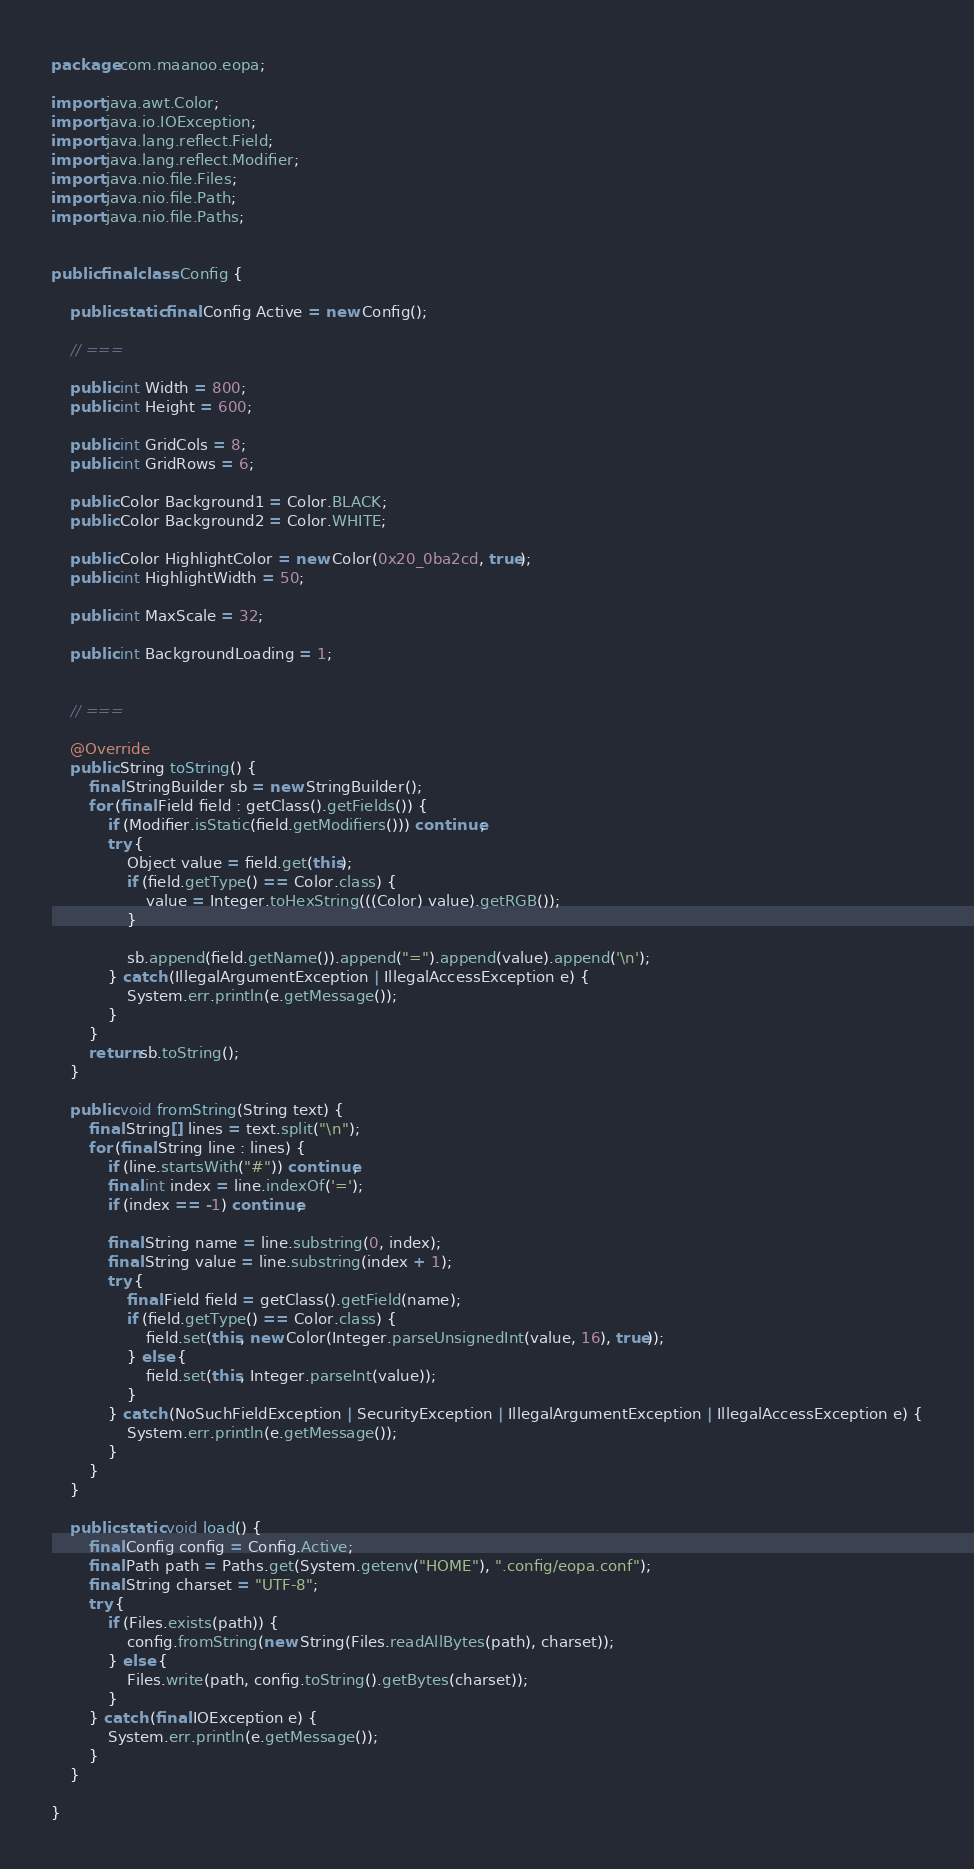Convert code to text. <code><loc_0><loc_0><loc_500><loc_500><_Java_>package com.maanoo.eopa;

import java.awt.Color;
import java.io.IOException;
import java.lang.reflect.Field;
import java.lang.reflect.Modifier;
import java.nio.file.Files;
import java.nio.file.Path;
import java.nio.file.Paths;


public final class Config {

    public static final Config Active = new Config();

    // ===

    public int Width = 800;
    public int Height = 600;

    public int GridCols = 8;
    public int GridRows = 6;

    public Color Background1 = Color.BLACK;
    public Color Background2 = Color.WHITE;

    public Color HighlightColor = new Color(0x20_0ba2cd, true);
    public int HighlightWidth = 50;

    public int MaxScale = 32;

    public int BackgroundLoading = 1;


    // ===

    @Override
    public String toString() {
        final StringBuilder sb = new StringBuilder();
        for (final Field field : getClass().getFields()) {
            if (Modifier.isStatic(field.getModifiers())) continue;
            try {
                Object value = field.get(this);
                if (field.getType() == Color.class) {
                    value = Integer.toHexString(((Color) value).getRGB());
                }

                sb.append(field.getName()).append("=").append(value).append('\n');
            } catch (IllegalArgumentException | IllegalAccessException e) {
                System.err.println(e.getMessage());
            }
        }
        return sb.toString();
    }

    public void fromString(String text) {
        final String[] lines = text.split("\n");
        for (final String line : lines) {
            if (line.startsWith("#")) continue;
            final int index = line.indexOf('=');
            if (index == -1) continue;

            final String name = line.substring(0, index);
            final String value = line.substring(index + 1);
            try {
                final Field field = getClass().getField(name);
                if (field.getType() == Color.class) {
                    field.set(this, new Color(Integer.parseUnsignedInt(value, 16), true));
                } else {
                    field.set(this, Integer.parseInt(value));
                }
            } catch (NoSuchFieldException | SecurityException | IllegalArgumentException | IllegalAccessException e) {
                System.err.println(e.getMessage());
            }
        }
    }

    public static void load() {
        final Config config = Config.Active;
        final Path path = Paths.get(System.getenv("HOME"), ".config/eopa.conf");
        final String charset = "UTF-8";
        try {
            if (Files.exists(path)) {
                config.fromString(new String(Files.readAllBytes(path), charset));
            } else {
                Files.write(path, config.toString().getBytes(charset));
            }
        } catch (final IOException e) {
            System.err.println(e.getMessage());
        }
    }

}
</code> 